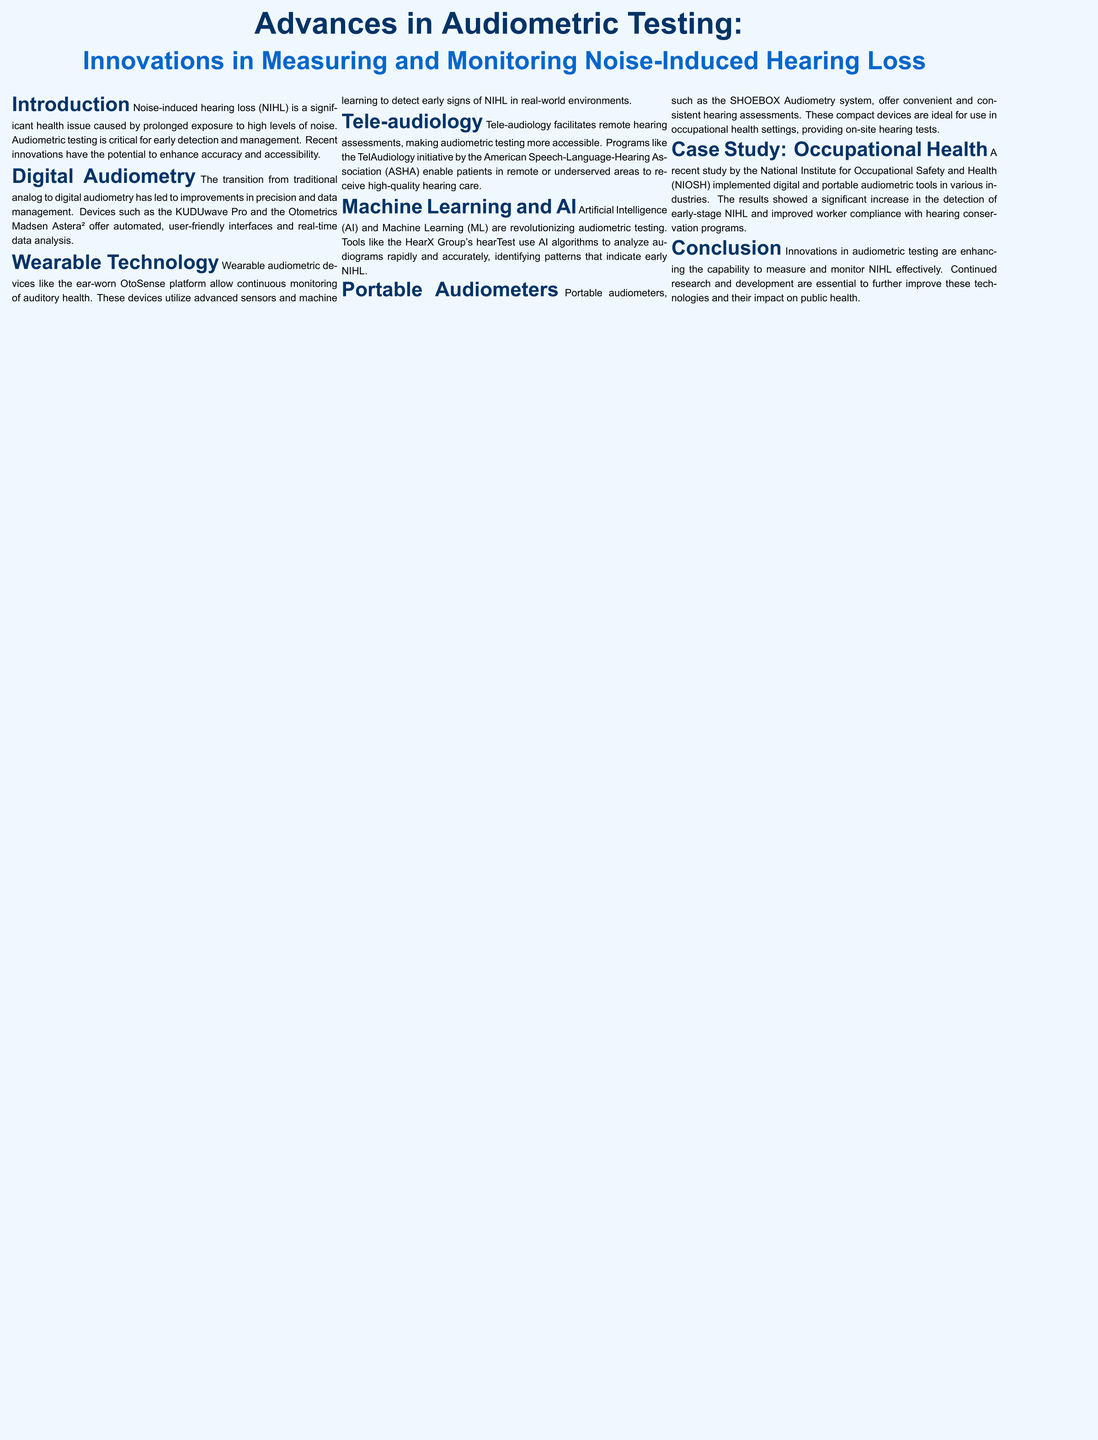What is NIHL? NIHL stands for noise-induced hearing loss, a significant health issue caused by prolonged exposure to high levels of noise.
Answer: noise-induced hearing loss What are two examples of digital audiometric devices? The document mentions the KUDUwave Pro and the Otometrics Madsen Astera² as digital audiometric devices.
Answer: KUDUwave Pro, Otometrics Madsen Astera² What is the purpose of wearable audiometric devices? Wearable audiometric devices like the OtoSense platform allow continuous monitoring of auditory health in real-world environments.
Answer: continuous monitoring of auditory health What initiative does tele-audiology facilitate? Tele-audiology facilitates remote hearing assessments, making audiometric testing more accessible.
Answer: remote hearing assessments Which organization is associated with the TelAudiology initiative? The TelAudiology initiative is associated with the American Speech-Language-Hearing Association (ASHA).
Answer: American Speech-Language-Hearing Association (ASHA) What technology is being used to analyze audiograms in the document? The document states that AI and Machine Learning are used to analyze audiograms rapidly and accurately.
Answer: AI and Machine Learning What compact device is mentioned for on-site hearing tests? The SHOEBOX Audiometry system is mentioned as a portable audiometer for convenient on-site hearing tests.
Answer: SHOEBOX Audiometry system What was a significant outcome of the NIOSH study? The study found a significant increase in the detection of early-stage NIHL and improved worker compliance with hearing conservation programs.
Answer: significant increase in the detection of early-stage NIHL What are the implications of advances in audiometric testing according to the conclusion? The conclusion states that innovations are enhancing the capability to measure and monitor NIHL effectively, impacting public health.
Answer: enhancing the capability to measure and monitor NIHL effectively 